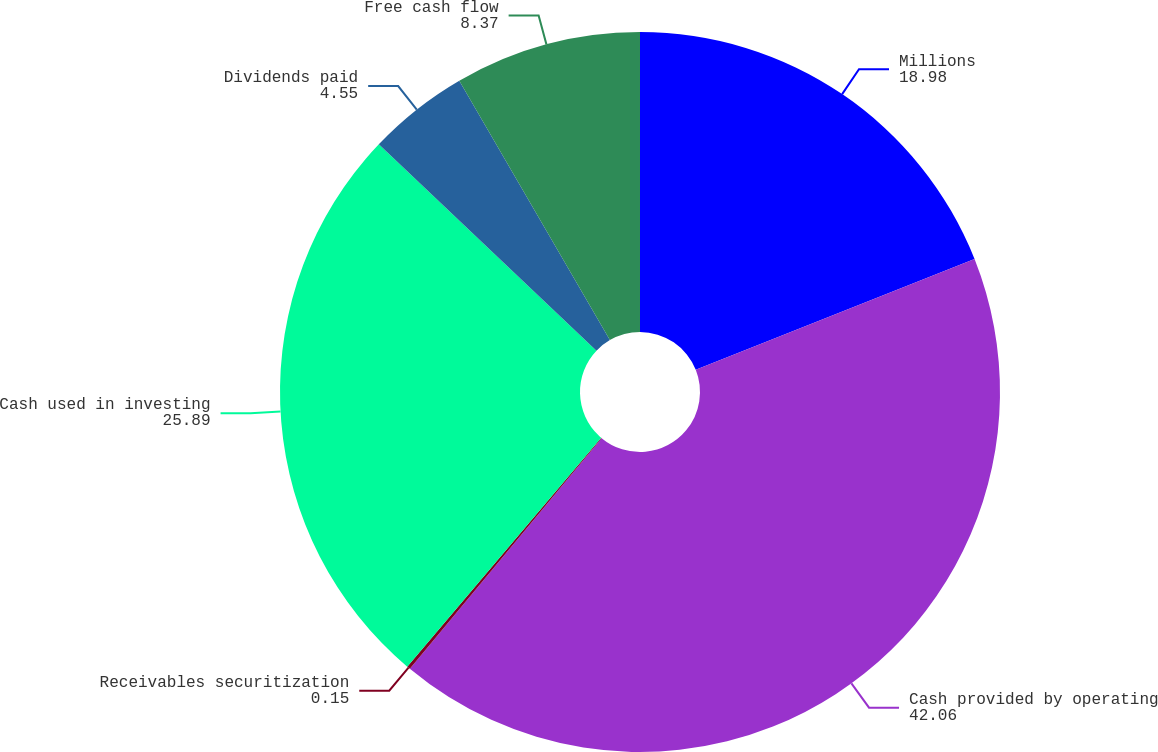Convert chart. <chart><loc_0><loc_0><loc_500><loc_500><pie_chart><fcel>Millions<fcel>Cash provided by operating<fcel>Receivables securitization<fcel>Cash used in investing<fcel>Dividends paid<fcel>Free cash flow<nl><fcel>18.98%<fcel>42.06%<fcel>0.15%<fcel>25.89%<fcel>4.55%<fcel>8.37%<nl></chart> 